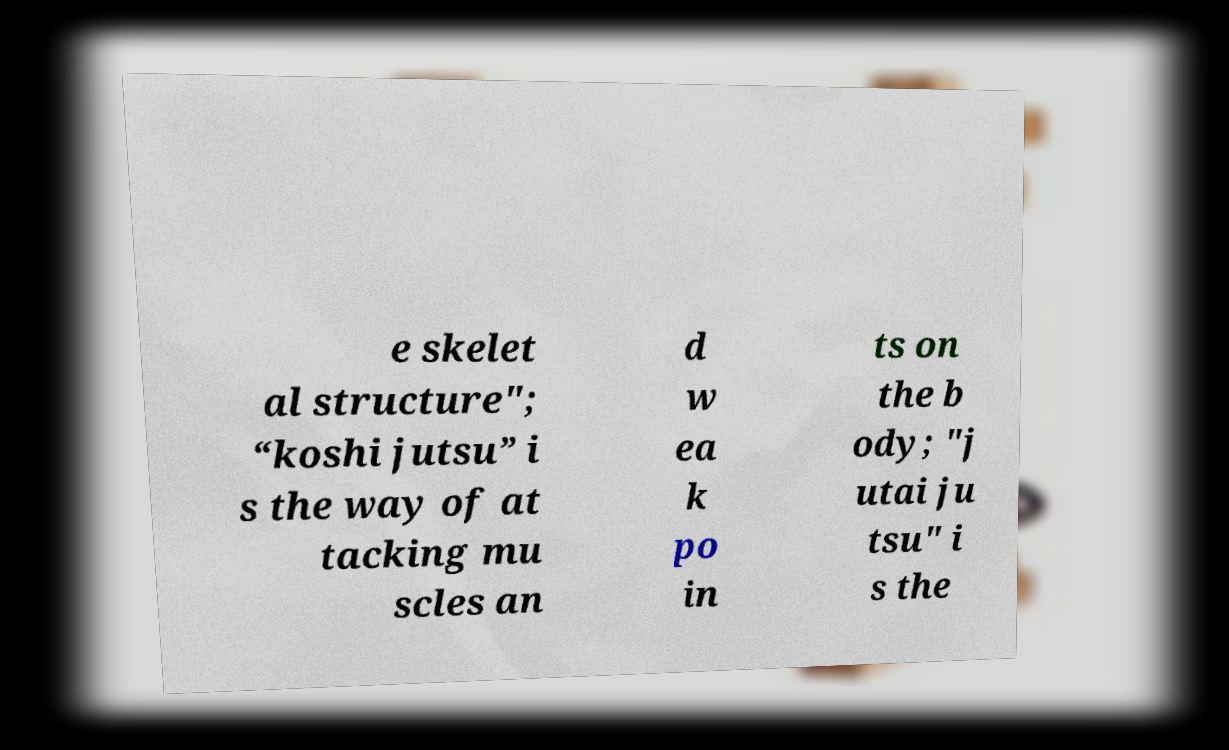Please identify and transcribe the text found in this image. e skelet al structure"; “koshi jutsu” i s the way of at tacking mu scles an d w ea k po in ts on the b ody; "j utai ju tsu" i s the 